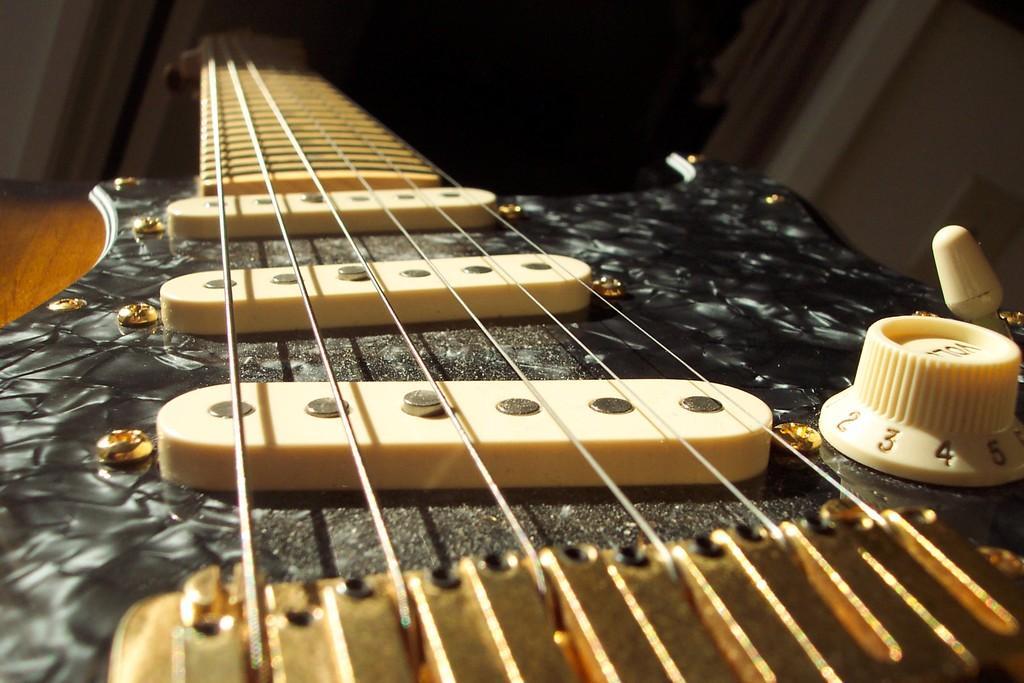How would you summarize this image in a sentence or two? In this image we can see the close view of a guitar placed on the wooden surface. The background of the image is dark. 